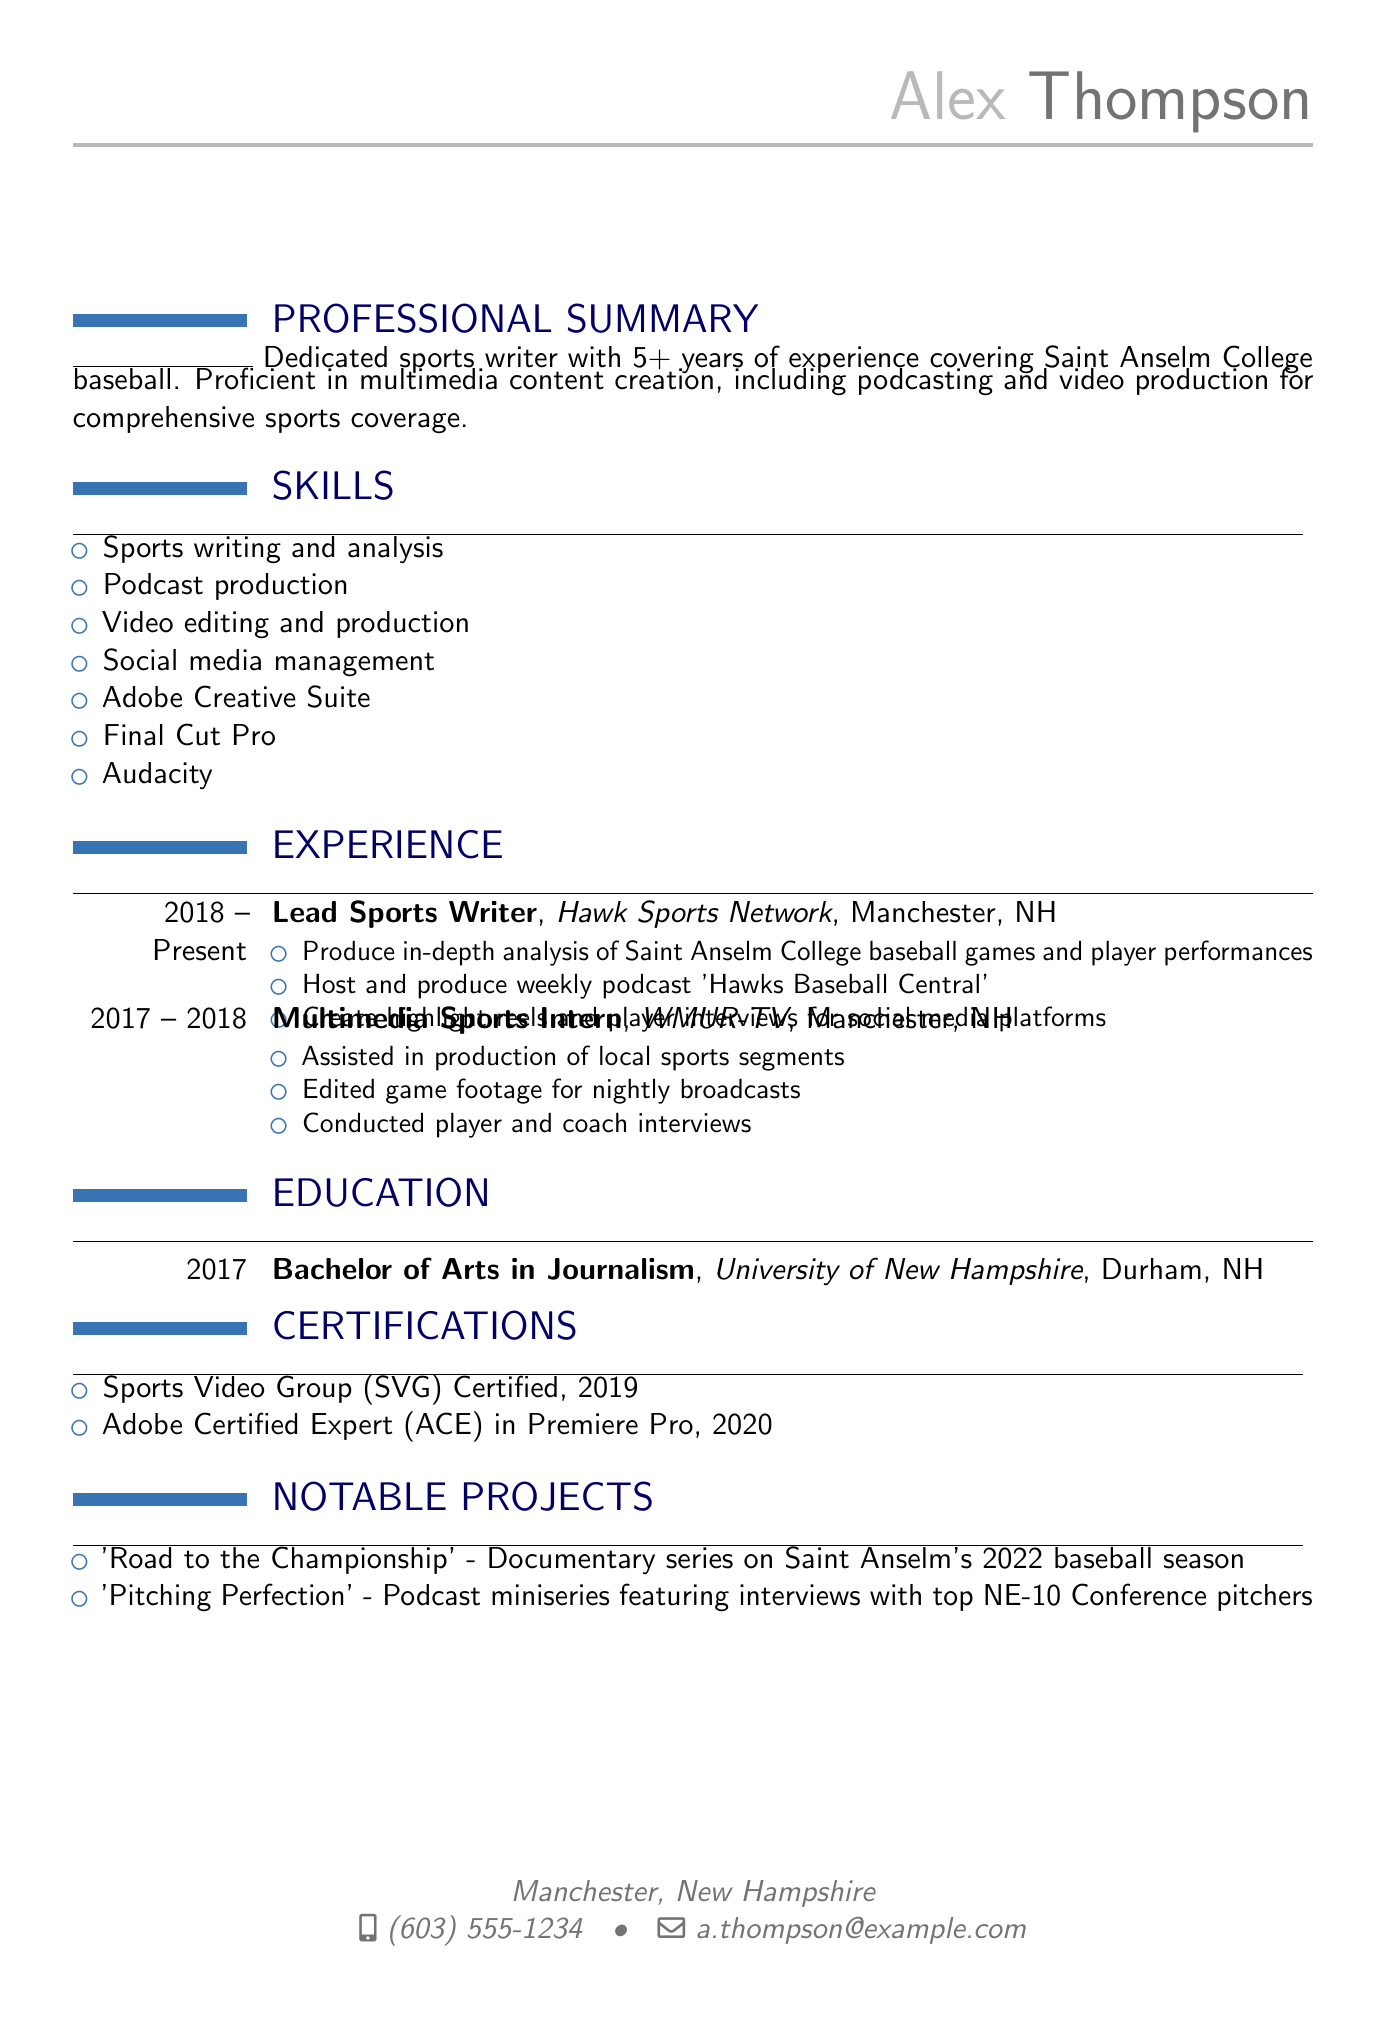what is the name of the person? The name of the person is at the top of the document under personal information.
Answer: Alex Thompson what is the location of the applicant? The location is provided in the personal information section.
Answer: Manchester, New Hampshire how many years of experience does Alex Thompson have? The professional summary states the number of years of experience.
Answer: 5+ what is the title of the podcast hosted by Alex Thompson? The responsibilities in the experience section indicate the title of the podcast.
Answer: Hawks Baseball Central which company did Alex work for as a multimedia sports intern? The experience section lists the company where Alex interned.
Answer: WMUR-TV what degree did Alex Thompson obtain? The education section specifies the degree earned by Alex.
Answer: Bachelor of Arts in Journalism what year did Alex graduate from university? The education section also provides the graduation year.
Answer: 2017 name one of the notable projects completed by Alex. The notable projects section identifies specific projects undertaken by Alex.
Answer: Road to the Championship how many skills are listed in the CV? The skills section enumerates specific skills, which can be counted.
Answer: 7 what certification did Alex obtain in 2019? The certifications section provides details about the certifications earned, including the year.
Answer: Sports Video Group (SVG) Certified 